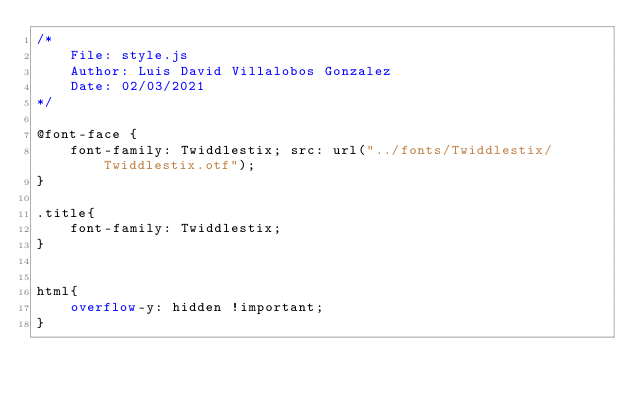<code> <loc_0><loc_0><loc_500><loc_500><_CSS_>/*
    File: style.js
    Author: Luis David Villalobos Gonzalez
    Date: 02/03/2021
*/

@font-face {
    font-family: Twiddlestix; src: url("../fonts/Twiddlestix/Twiddlestix.otf");
}

.title{
    font-family: Twiddlestix;
}


html{
    overflow-y: hidden !important;
}</code> 